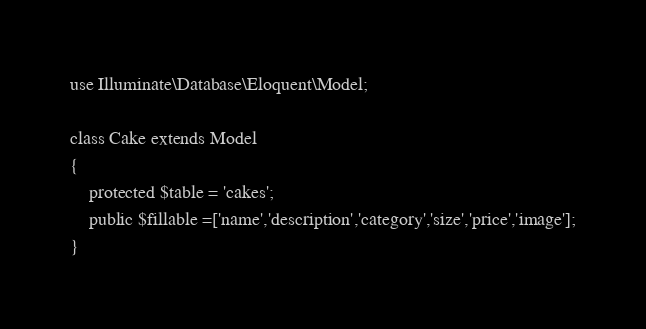Convert code to text. <code><loc_0><loc_0><loc_500><loc_500><_PHP_>use Illuminate\Database\Eloquent\Model;

class Cake extends Model
{
    protected $table = 'cakes';
    public $fillable =['name','description','category','size','price','image'];
}
</code> 